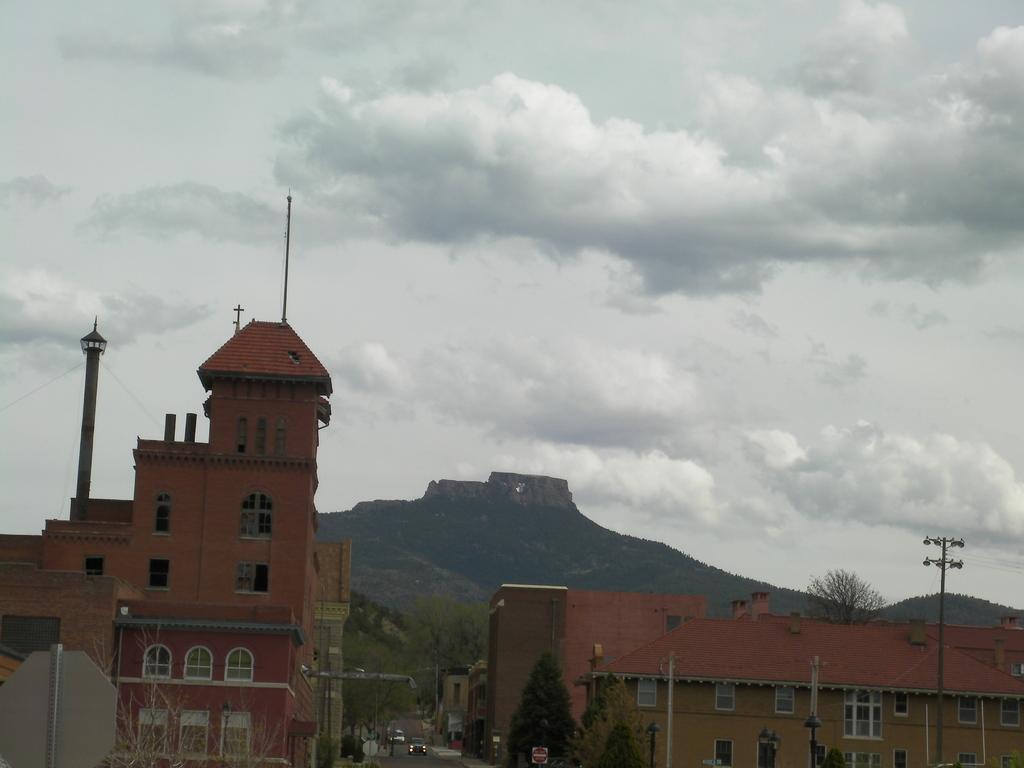Please provide a concise description of this image. There are trees and buildings at the bottom of this image and we can see a mountain in the background. There is a cloudy sky at the top of this image. 